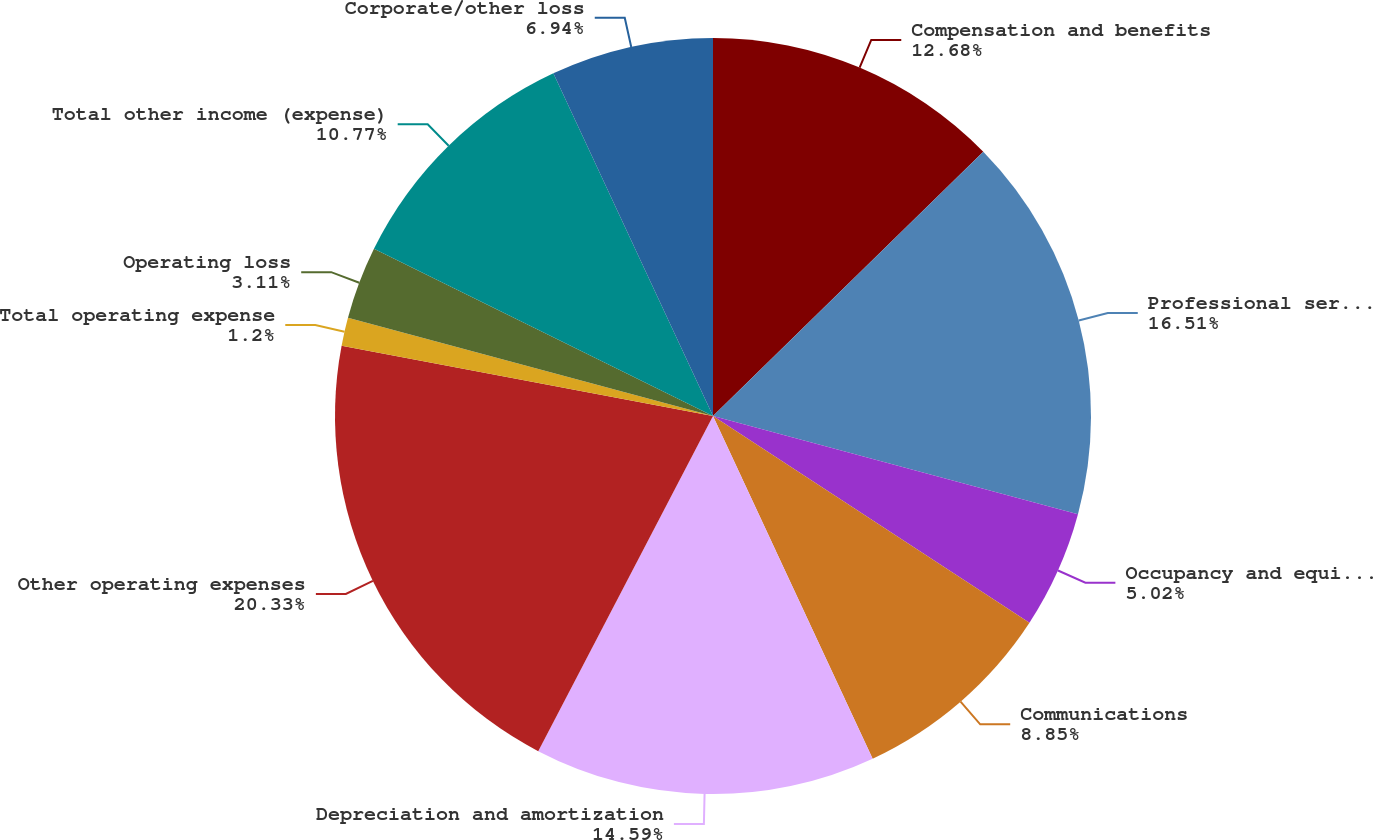<chart> <loc_0><loc_0><loc_500><loc_500><pie_chart><fcel>Compensation and benefits<fcel>Professional services<fcel>Occupancy and equipment<fcel>Communications<fcel>Depreciation and amortization<fcel>Other operating expenses<fcel>Total operating expense<fcel>Operating loss<fcel>Total other income (expense)<fcel>Corporate/other loss<nl><fcel>12.68%<fcel>16.51%<fcel>5.02%<fcel>8.85%<fcel>14.59%<fcel>20.33%<fcel>1.2%<fcel>3.11%<fcel>10.77%<fcel>6.94%<nl></chart> 